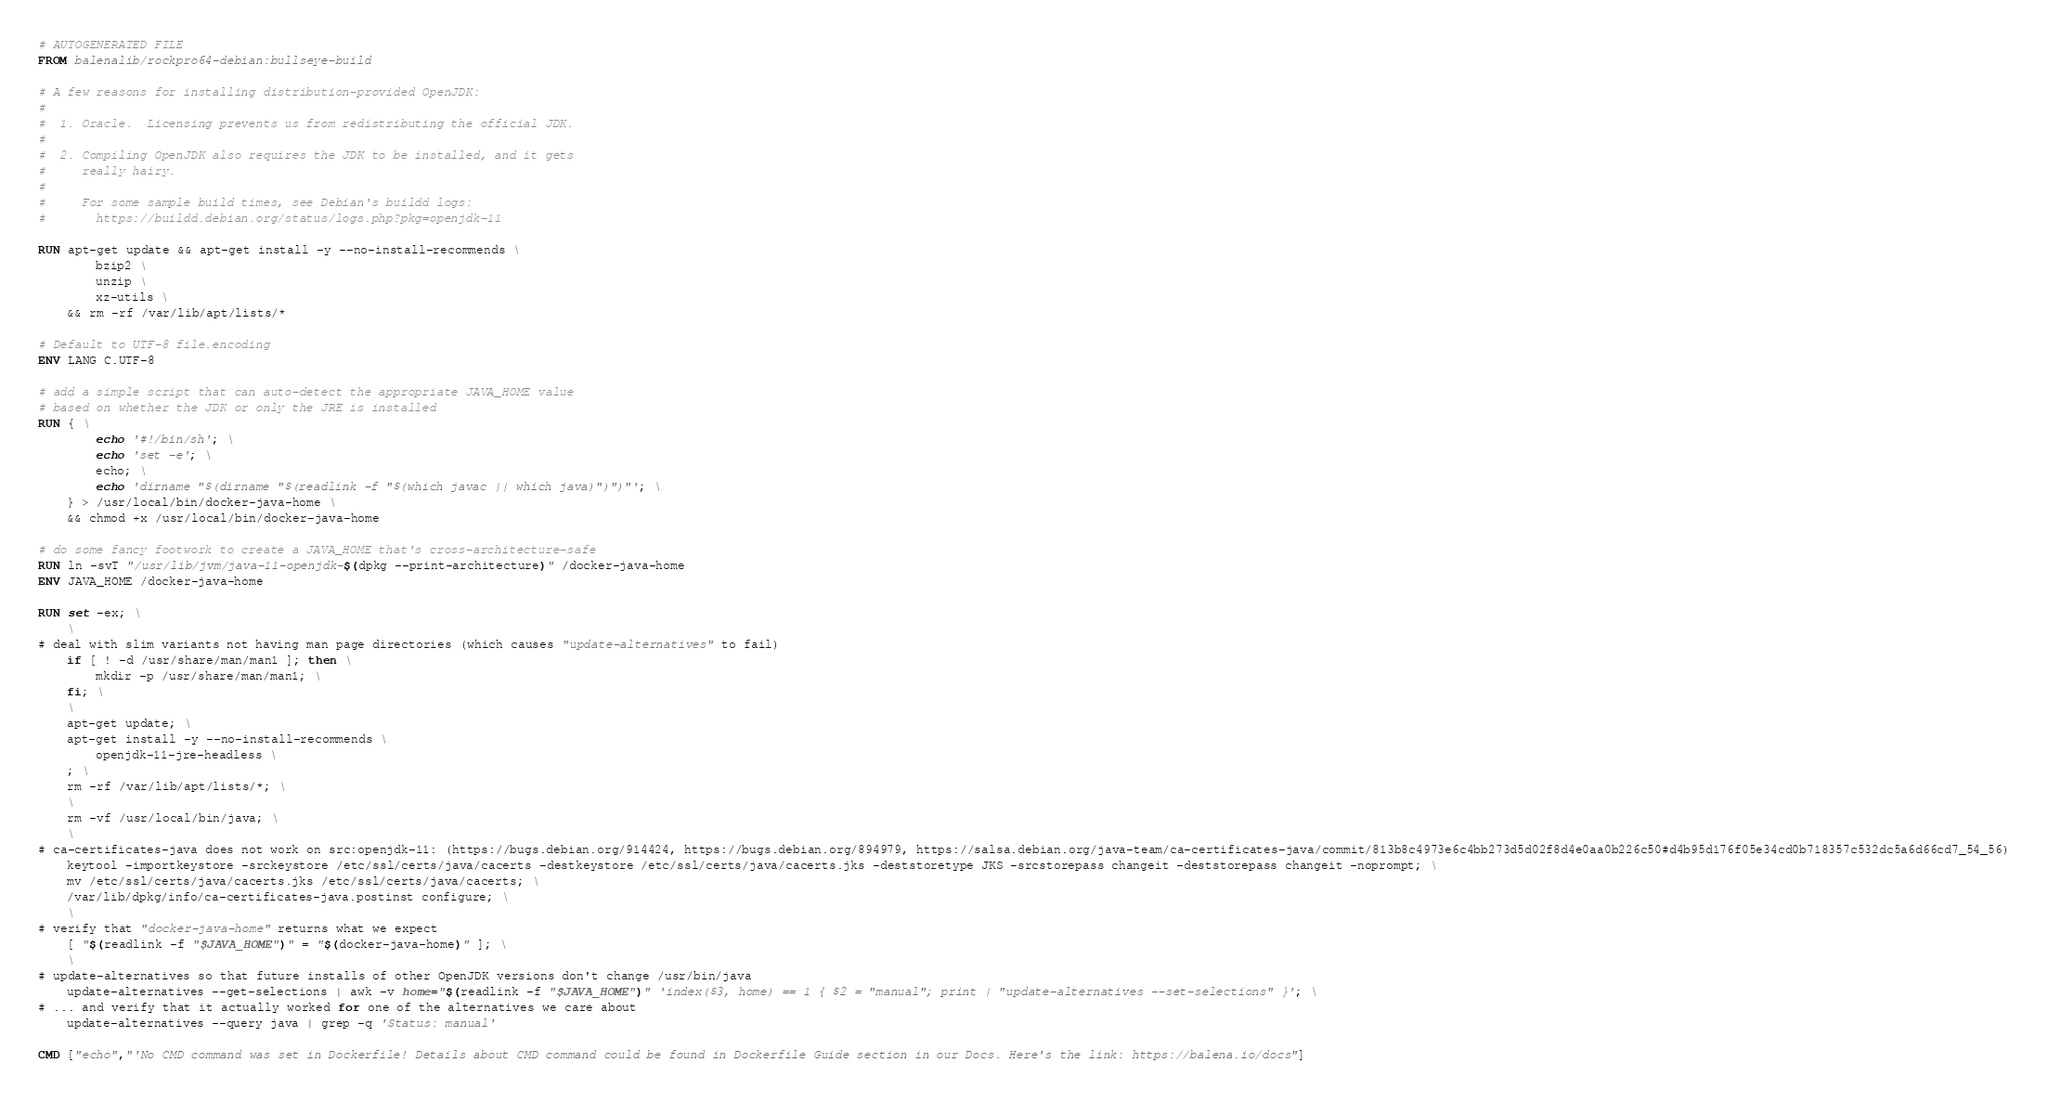Convert code to text. <code><loc_0><loc_0><loc_500><loc_500><_Dockerfile_># AUTOGENERATED FILE
FROM balenalib/rockpro64-debian:bullseye-build

# A few reasons for installing distribution-provided OpenJDK:
#
#  1. Oracle.  Licensing prevents us from redistributing the official JDK.
#
#  2. Compiling OpenJDK also requires the JDK to be installed, and it gets
#     really hairy.
#
#     For some sample build times, see Debian's buildd logs:
#       https://buildd.debian.org/status/logs.php?pkg=openjdk-11

RUN apt-get update && apt-get install -y --no-install-recommends \
		bzip2 \
		unzip \
		xz-utils \
	&& rm -rf /var/lib/apt/lists/*

# Default to UTF-8 file.encoding
ENV LANG C.UTF-8

# add a simple script that can auto-detect the appropriate JAVA_HOME value
# based on whether the JDK or only the JRE is installed
RUN { \
		echo '#!/bin/sh'; \
		echo 'set -e'; \
		echo; \
		echo 'dirname "$(dirname "$(readlink -f "$(which javac || which java)")")"'; \
	} > /usr/local/bin/docker-java-home \
	&& chmod +x /usr/local/bin/docker-java-home

# do some fancy footwork to create a JAVA_HOME that's cross-architecture-safe
RUN ln -svT "/usr/lib/jvm/java-11-openjdk-$(dpkg --print-architecture)" /docker-java-home
ENV JAVA_HOME /docker-java-home

RUN set -ex; \
	\
# deal with slim variants not having man page directories (which causes "update-alternatives" to fail)
	if [ ! -d /usr/share/man/man1 ]; then \
		mkdir -p /usr/share/man/man1; \
	fi; \
	\
	apt-get update; \
	apt-get install -y --no-install-recommends \
		openjdk-11-jre-headless \
	; \
	rm -rf /var/lib/apt/lists/*; \
	\
	rm -vf /usr/local/bin/java; \
	\
# ca-certificates-java does not work on src:openjdk-11: (https://bugs.debian.org/914424, https://bugs.debian.org/894979, https://salsa.debian.org/java-team/ca-certificates-java/commit/813b8c4973e6c4bb273d5d02f8d4e0aa0b226c50#d4b95d176f05e34cd0b718357c532dc5a6d66cd7_54_56)
	keytool -importkeystore -srckeystore /etc/ssl/certs/java/cacerts -destkeystore /etc/ssl/certs/java/cacerts.jks -deststoretype JKS -srcstorepass changeit -deststorepass changeit -noprompt; \
	mv /etc/ssl/certs/java/cacerts.jks /etc/ssl/certs/java/cacerts; \
	/var/lib/dpkg/info/ca-certificates-java.postinst configure; \
	\
# verify that "docker-java-home" returns what we expect
	[ "$(readlink -f "$JAVA_HOME")" = "$(docker-java-home)" ]; \
	\
# update-alternatives so that future installs of other OpenJDK versions don't change /usr/bin/java
	update-alternatives --get-selections | awk -v home="$(readlink -f "$JAVA_HOME")" 'index($3, home) == 1 { $2 = "manual"; print | "update-alternatives --set-selections" }'; \
# ... and verify that it actually worked for one of the alternatives we care about
	update-alternatives --query java | grep -q 'Status: manual'

CMD ["echo","'No CMD command was set in Dockerfile! Details about CMD command could be found in Dockerfile Guide section in our Docs. Here's the link: https://balena.io/docs"]
</code> 